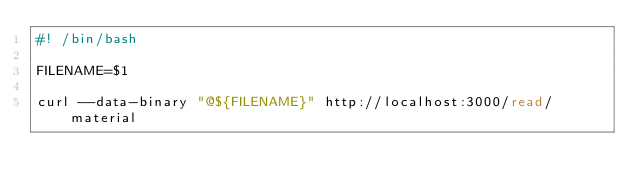Convert code to text. <code><loc_0><loc_0><loc_500><loc_500><_Bash_>#! /bin/bash

FILENAME=$1

curl --data-binary "@${FILENAME}" http://localhost:3000/read/material
</code> 